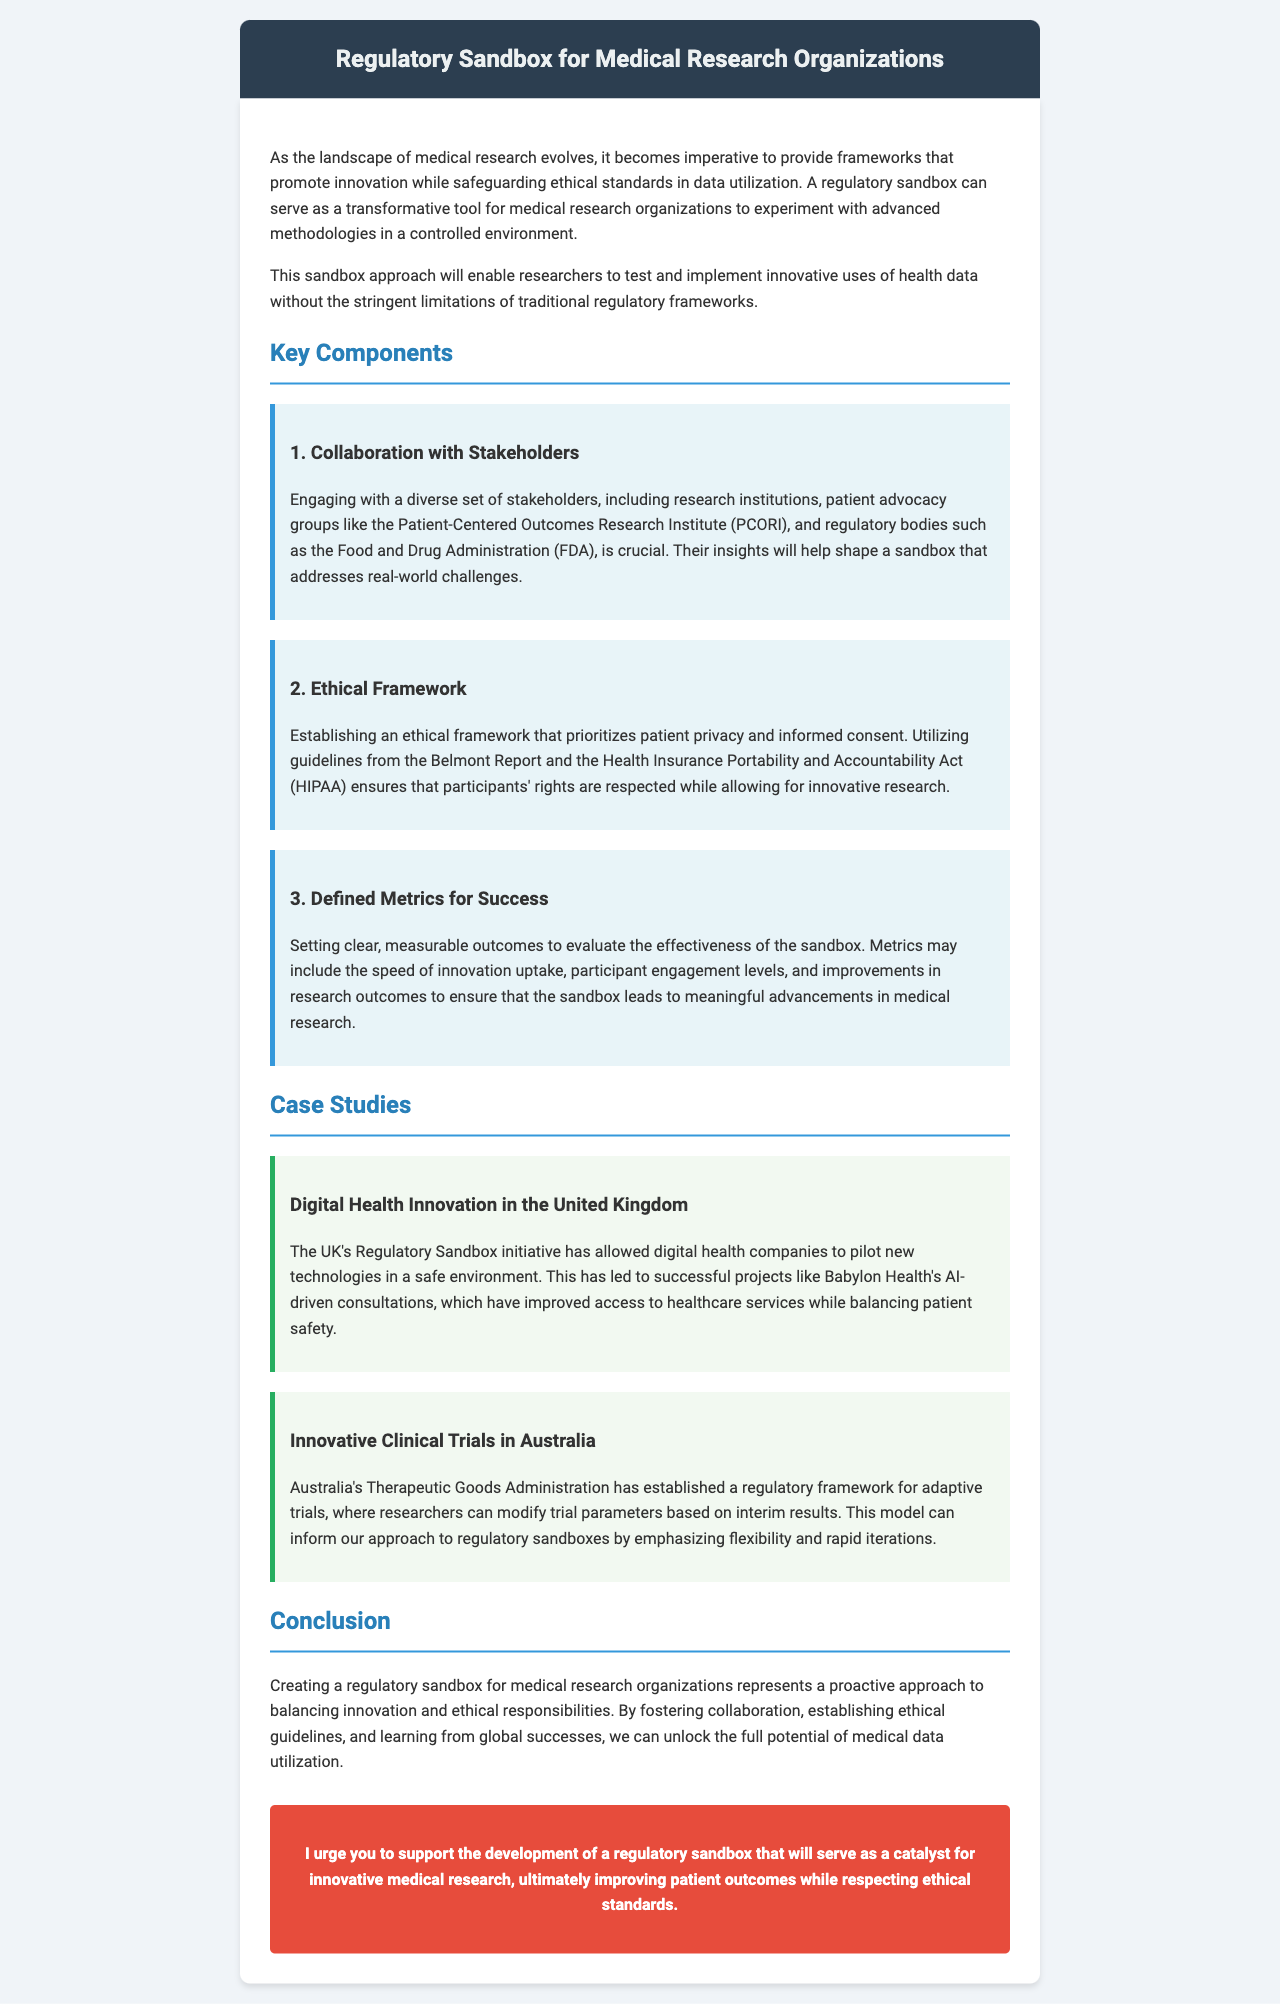What is the main purpose of the regulatory sandbox? The main purpose is to promote innovation while safeguarding ethical standards in data utilization.
Answer: To promote innovation while safeguarding ethical standards in data utilization What organization provides patient advocacy insights? The letter mentions the Patient-Centered Outcomes Research Institute (PCORI) as a key stakeholder for insights.
Answer: Patient-Centered Outcomes Research Institute (PCORI) Which report's guidelines are utilized for the ethical framework? The Belmont Report's guidelines are part of the ethical framework mentioned in the document.
Answer: Belmont Report What country has a regulatory sandbox for digital health? The UK is cited as having a regulatory sandbox initiative for digital health.
Answer: UK What is one of the key components listed in the document? The document outlines collaboration with stakeholders as a key component of the sandbox framework.
Answer: Collaboration with Stakeholders How does the UK regulatory sandbox benefit healthcare? It has led to improved access to healthcare services.
Answer: Improved access to healthcare services What does Australia’s regulatory framework allow researchers to do? It allows researchers to modify trial parameters based on interim results.
Answer: Modify trial parameters based on interim results What is the suggested outcome of the regulatory sandbox? The ultimate goal is to improve patient outcomes while respecting ethical standards.
Answer: Improve patient outcomes while respecting ethical standards 